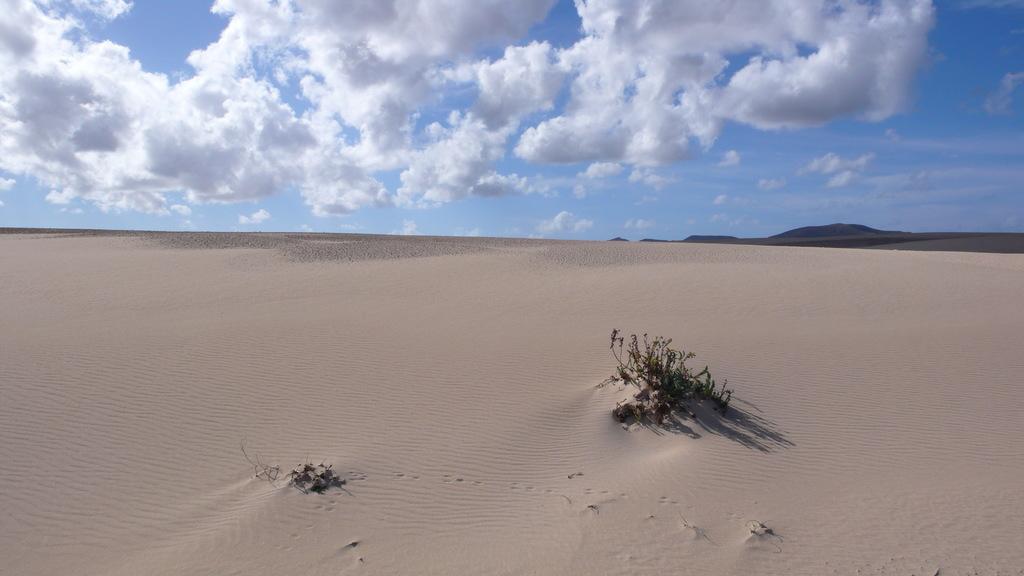In one or two sentences, can you explain what this image depicts? In this picture we can see a plant, sand and hills. At the top of the image, there is the sky. 